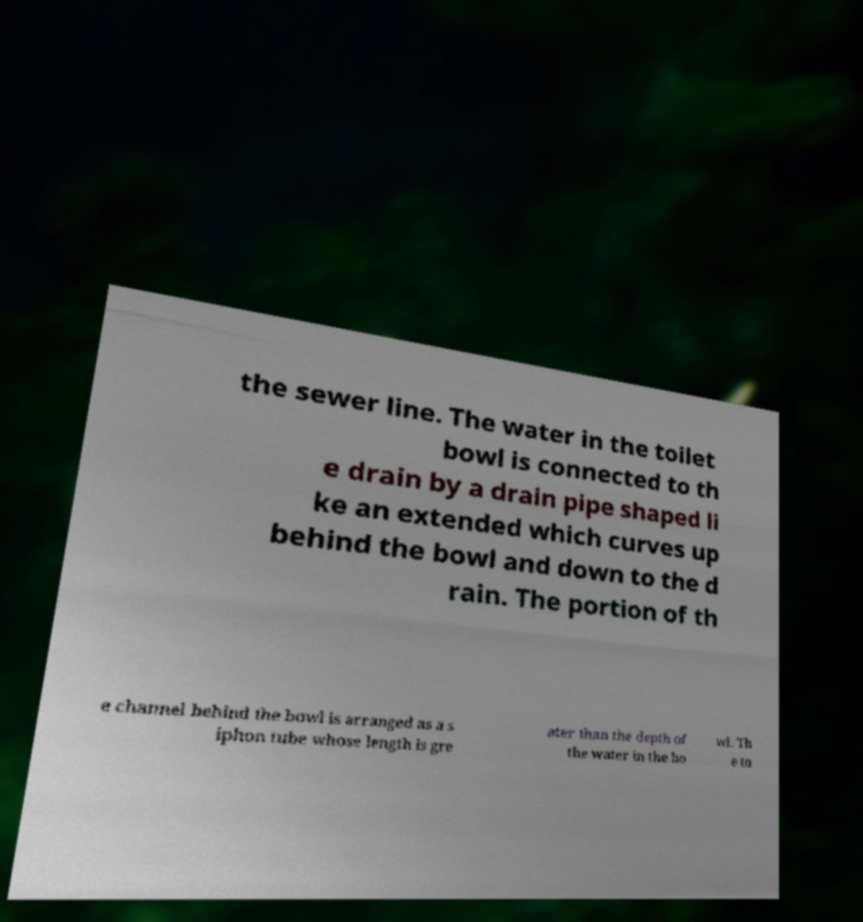I need the written content from this picture converted into text. Can you do that? the sewer line. The water in the toilet bowl is connected to th e drain by a drain pipe shaped li ke an extended which curves up behind the bowl and down to the d rain. The portion of th e channel behind the bowl is arranged as a s iphon tube whose length is gre ater than the depth of the water in the bo wl. Th e to 